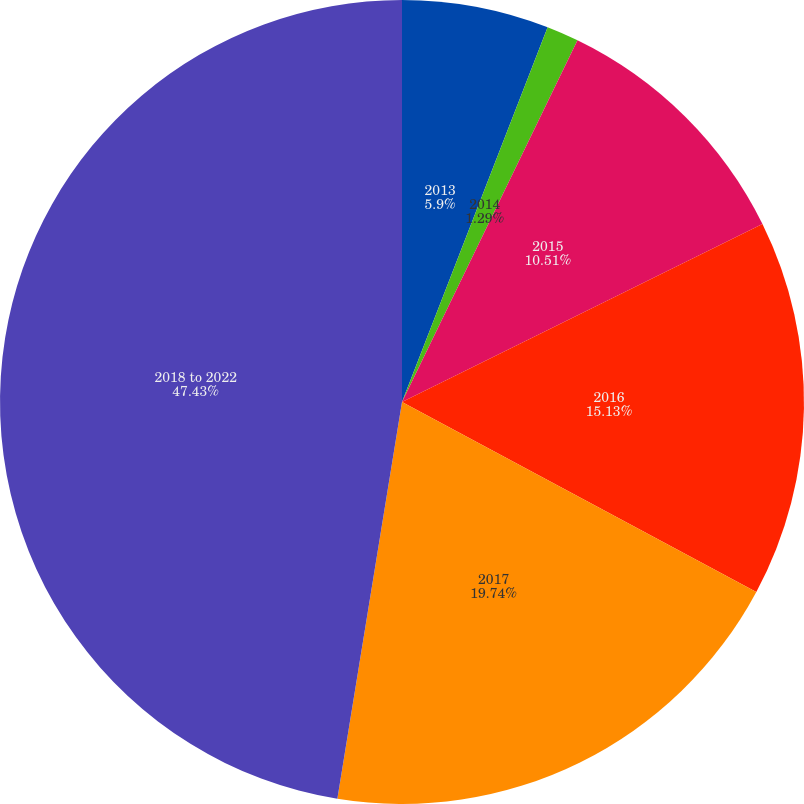Convert chart. <chart><loc_0><loc_0><loc_500><loc_500><pie_chart><fcel>2013<fcel>2014<fcel>2015<fcel>2016<fcel>2017<fcel>2018 to 2022<nl><fcel>5.9%<fcel>1.29%<fcel>10.51%<fcel>15.13%<fcel>19.74%<fcel>47.43%<nl></chart> 